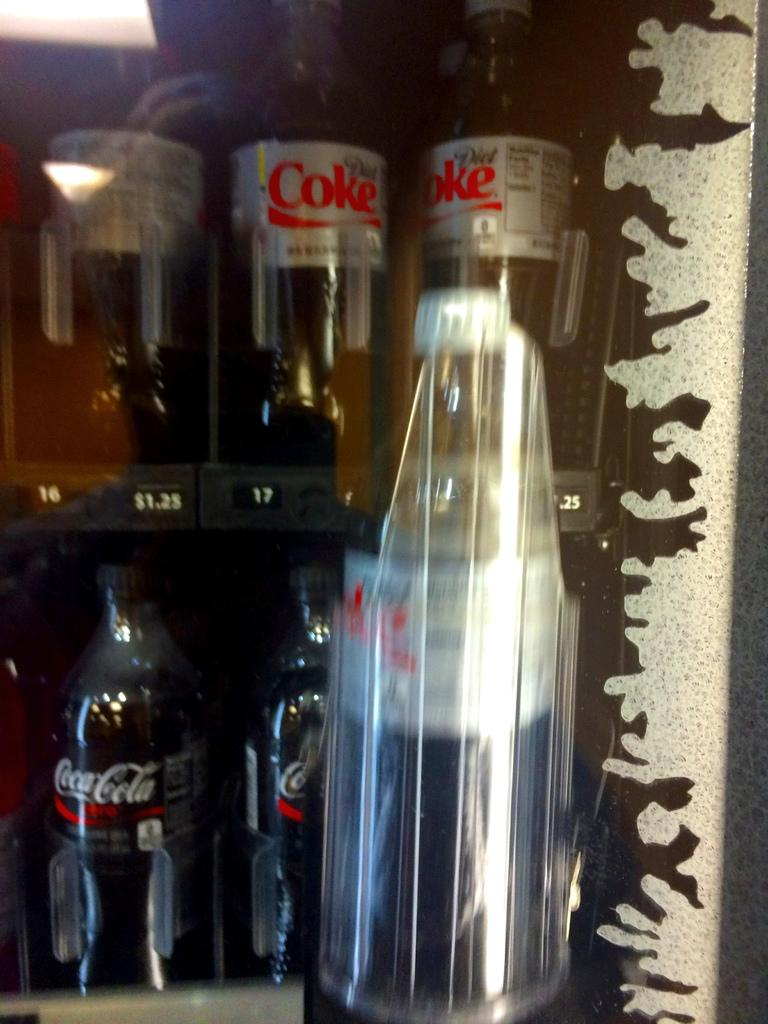Provide a one-sentence caption for the provided image. A selection of assorted Coca Cola products chill in a frosty refrigerator. 